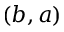Convert formula to latex. <formula><loc_0><loc_0><loc_500><loc_500>( b , a )</formula> 